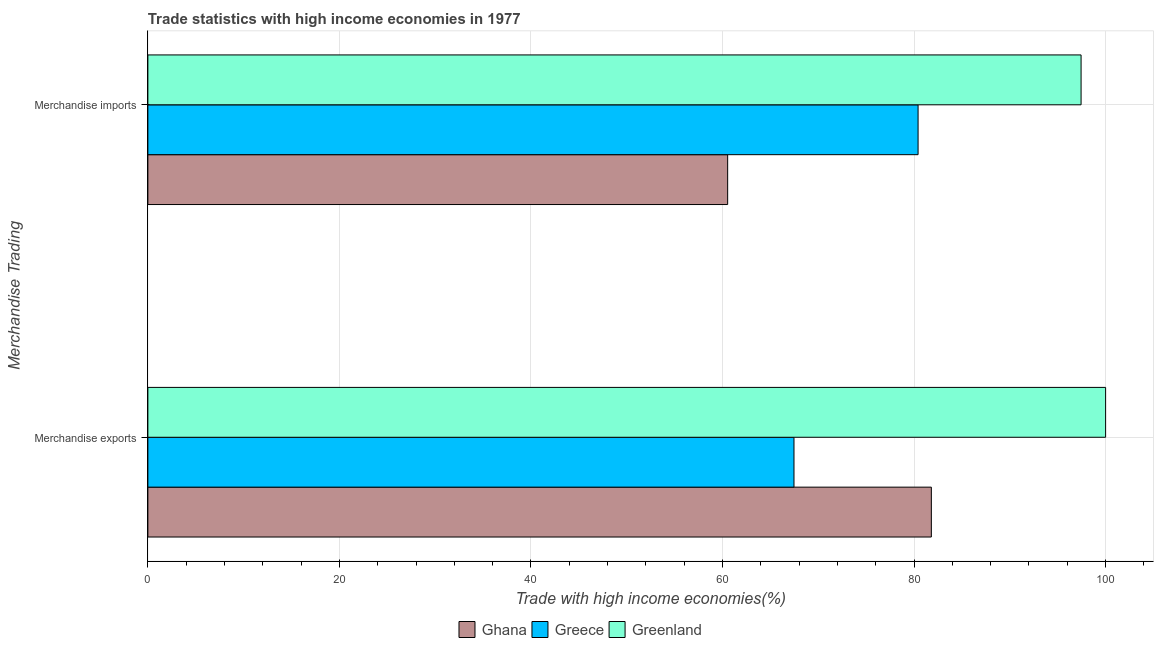How many groups of bars are there?
Ensure brevity in your answer.  2. Are the number of bars per tick equal to the number of legend labels?
Offer a terse response. Yes. Are the number of bars on each tick of the Y-axis equal?
Keep it short and to the point. Yes. How many bars are there on the 1st tick from the bottom?
Your response must be concise. 3. What is the label of the 2nd group of bars from the top?
Make the answer very short. Merchandise exports. What is the merchandise exports in Greece?
Provide a short and direct response. 67.46. Across all countries, what is the minimum merchandise exports?
Offer a terse response. 67.46. In which country was the merchandise imports maximum?
Keep it short and to the point. Greenland. What is the total merchandise exports in the graph?
Ensure brevity in your answer.  249.27. What is the difference between the merchandise imports in Greece and that in Ghana?
Keep it short and to the point. 19.88. What is the difference between the merchandise imports in Greenland and the merchandise exports in Greece?
Your answer should be very brief. 29.98. What is the average merchandise imports per country?
Provide a succinct answer. 79.47. What is the difference between the merchandise imports and merchandise exports in Greece?
Your answer should be compact. 12.96. In how many countries, is the merchandise exports greater than 48 %?
Offer a very short reply. 3. What is the ratio of the merchandise imports in Greece to that in Greenland?
Offer a very short reply. 0.83. Is the merchandise imports in Ghana less than that in Greenland?
Keep it short and to the point. Yes. In how many countries, is the merchandise imports greater than the average merchandise imports taken over all countries?
Offer a very short reply. 2. What does the 2nd bar from the top in Merchandise imports represents?
Provide a short and direct response. Greece. What does the 3rd bar from the bottom in Merchandise imports represents?
Offer a very short reply. Greenland. How many bars are there?
Give a very brief answer. 6. How many countries are there in the graph?
Your answer should be very brief. 3. What is the difference between two consecutive major ticks on the X-axis?
Your answer should be very brief. 20. Does the graph contain grids?
Make the answer very short. Yes. Where does the legend appear in the graph?
Offer a very short reply. Bottom center. How many legend labels are there?
Ensure brevity in your answer.  3. What is the title of the graph?
Your answer should be very brief. Trade statistics with high income economies in 1977. Does "Pacific island small states" appear as one of the legend labels in the graph?
Offer a very short reply. No. What is the label or title of the X-axis?
Make the answer very short. Trade with high income economies(%). What is the label or title of the Y-axis?
Keep it short and to the point. Merchandise Trading. What is the Trade with high income economies(%) of Ghana in Merchandise exports?
Provide a short and direct response. 81.8. What is the Trade with high income economies(%) of Greece in Merchandise exports?
Your response must be concise. 67.46. What is the Trade with high income economies(%) of Ghana in Merchandise imports?
Your answer should be compact. 60.54. What is the Trade with high income economies(%) in Greece in Merchandise imports?
Give a very brief answer. 80.42. What is the Trade with high income economies(%) in Greenland in Merchandise imports?
Give a very brief answer. 97.44. Across all Merchandise Trading, what is the maximum Trade with high income economies(%) of Ghana?
Provide a succinct answer. 81.8. Across all Merchandise Trading, what is the maximum Trade with high income economies(%) in Greece?
Provide a short and direct response. 80.42. Across all Merchandise Trading, what is the maximum Trade with high income economies(%) in Greenland?
Offer a very short reply. 100. Across all Merchandise Trading, what is the minimum Trade with high income economies(%) of Ghana?
Provide a short and direct response. 60.54. Across all Merchandise Trading, what is the minimum Trade with high income economies(%) in Greece?
Ensure brevity in your answer.  67.46. Across all Merchandise Trading, what is the minimum Trade with high income economies(%) of Greenland?
Make the answer very short. 97.44. What is the total Trade with high income economies(%) of Ghana in the graph?
Make the answer very short. 142.34. What is the total Trade with high income economies(%) in Greece in the graph?
Ensure brevity in your answer.  147.88. What is the total Trade with high income economies(%) in Greenland in the graph?
Provide a succinct answer. 197.44. What is the difference between the Trade with high income economies(%) in Ghana in Merchandise exports and that in Merchandise imports?
Give a very brief answer. 21.27. What is the difference between the Trade with high income economies(%) in Greece in Merchandise exports and that in Merchandise imports?
Your answer should be compact. -12.96. What is the difference between the Trade with high income economies(%) in Greenland in Merchandise exports and that in Merchandise imports?
Provide a short and direct response. 2.56. What is the difference between the Trade with high income economies(%) in Ghana in Merchandise exports and the Trade with high income economies(%) in Greece in Merchandise imports?
Offer a terse response. 1.38. What is the difference between the Trade with high income economies(%) of Ghana in Merchandise exports and the Trade with high income economies(%) of Greenland in Merchandise imports?
Your answer should be compact. -15.63. What is the difference between the Trade with high income economies(%) in Greece in Merchandise exports and the Trade with high income economies(%) in Greenland in Merchandise imports?
Ensure brevity in your answer.  -29.98. What is the average Trade with high income economies(%) in Ghana per Merchandise Trading?
Ensure brevity in your answer.  71.17. What is the average Trade with high income economies(%) of Greece per Merchandise Trading?
Your answer should be very brief. 73.94. What is the average Trade with high income economies(%) in Greenland per Merchandise Trading?
Ensure brevity in your answer.  98.72. What is the difference between the Trade with high income economies(%) of Ghana and Trade with high income economies(%) of Greece in Merchandise exports?
Provide a short and direct response. 14.34. What is the difference between the Trade with high income economies(%) in Ghana and Trade with high income economies(%) in Greenland in Merchandise exports?
Ensure brevity in your answer.  -18.2. What is the difference between the Trade with high income economies(%) in Greece and Trade with high income economies(%) in Greenland in Merchandise exports?
Your answer should be very brief. -32.54. What is the difference between the Trade with high income economies(%) of Ghana and Trade with high income economies(%) of Greece in Merchandise imports?
Provide a succinct answer. -19.88. What is the difference between the Trade with high income economies(%) in Ghana and Trade with high income economies(%) in Greenland in Merchandise imports?
Provide a short and direct response. -36.9. What is the difference between the Trade with high income economies(%) in Greece and Trade with high income economies(%) in Greenland in Merchandise imports?
Offer a terse response. -17.02. What is the ratio of the Trade with high income economies(%) of Ghana in Merchandise exports to that in Merchandise imports?
Your answer should be very brief. 1.35. What is the ratio of the Trade with high income economies(%) in Greece in Merchandise exports to that in Merchandise imports?
Offer a terse response. 0.84. What is the ratio of the Trade with high income economies(%) of Greenland in Merchandise exports to that in Merchandise imports?
Provide a short and direct response. 1.03. What is the difference between the highest and the second highest Trade with high income economies(%) of Ghana?
Offer a terse response. 21.27. What is the difference between the highest and the second highest Trade with high income economies(%) in Greece?
Ensure brevity in your answer.  12.96. What is the difference between the highest and the second highest Trade with high income economies(%) in Greenland?
Ensure brevity in your answer.  2.56. What is the difference between the highest and the lowest Trade with high income economies(%) of Ghana?
Offer a very short reply. 21.27. What is the difference between the highest and the lowest Trade with high income economies(%) in Greece?
Offer a terse response. 12.96. What is the difference between the highest and the lowest Trade with high income economies(%) in Greenland?
Ensure brevity in your answer.  2.56. 